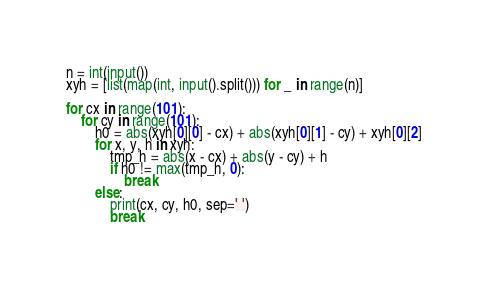Convert code to text. <code><loc_0><loc_0><loc_500><loc_500><_Python_>n = int(input())
xyh = [list(map(int, input().split())) for _ in range(n)]

for cx in range(101):
    for cy in range(101):
        h0 = abs(xyh[0][0] - cx) + abs(xyh[0][1] - cy) + xyh[0][2]
        for x, y, h in xyh:
            tmp_h = abs(x - cx) + abs(y - cy) + h
            if h0 != max(tmp_h, 0):
                break
        else:
            print(cx, cy, h0, sep=' ')
            break</code> 